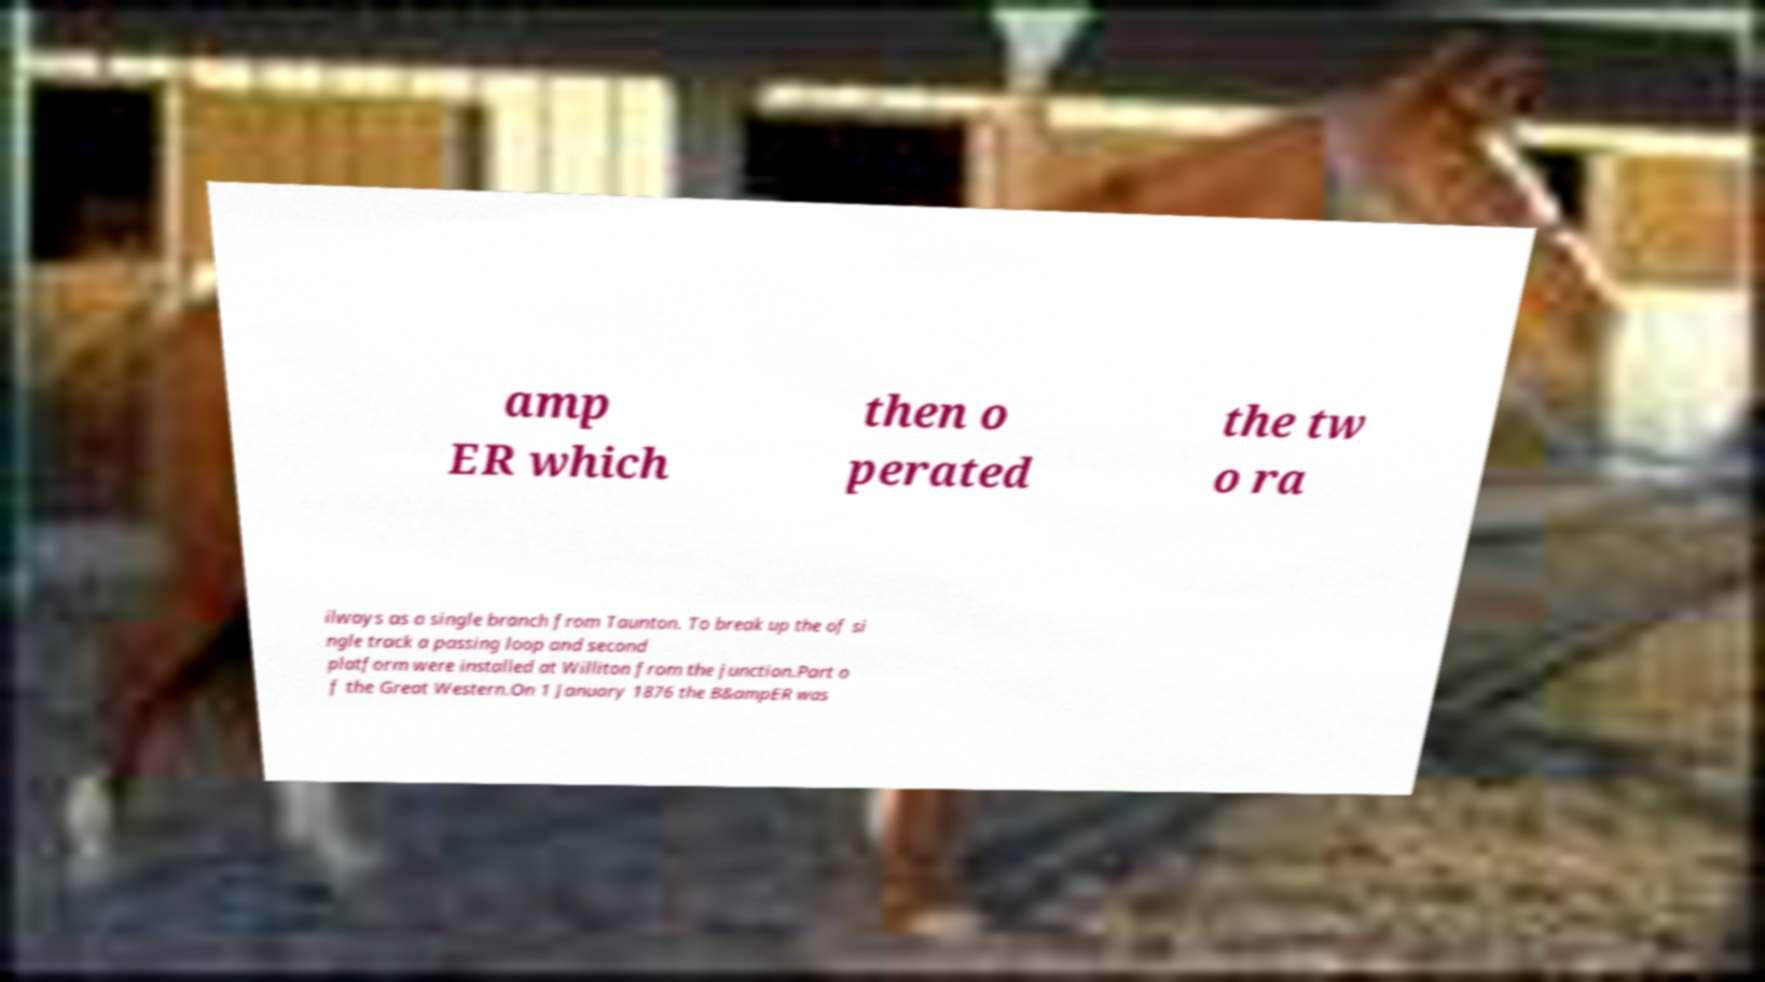Could you assist in decoding the text presented in this image and type it out clearly? amp ER which then o perated the tw o ra ilways as a single branch from Taunton. To break up the of si ngle track a passing loop and second platform were installed at Williton from the junction.Part o f the Great Western.On 1 January 1876 the B&ampER was 